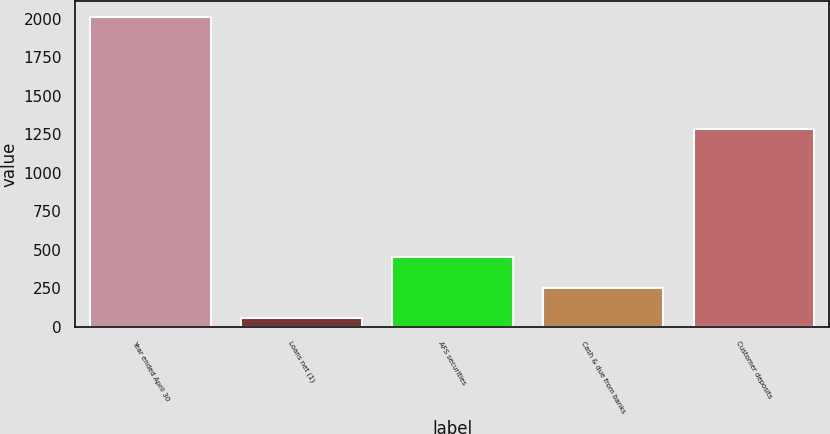Convert chart. <chart><loc_0><loc_0><loc_500><loc_500><bar_chart><fcel>Year ended April 30<fcel>Loans net (1)<fcel>AFS securities<fcel>Cash & due from banks<fcel>Customer deposits<nl><fcel>2013<fcel>60<fcel>450.6<fcel>255.3<fcel>1286<nl></chart> 